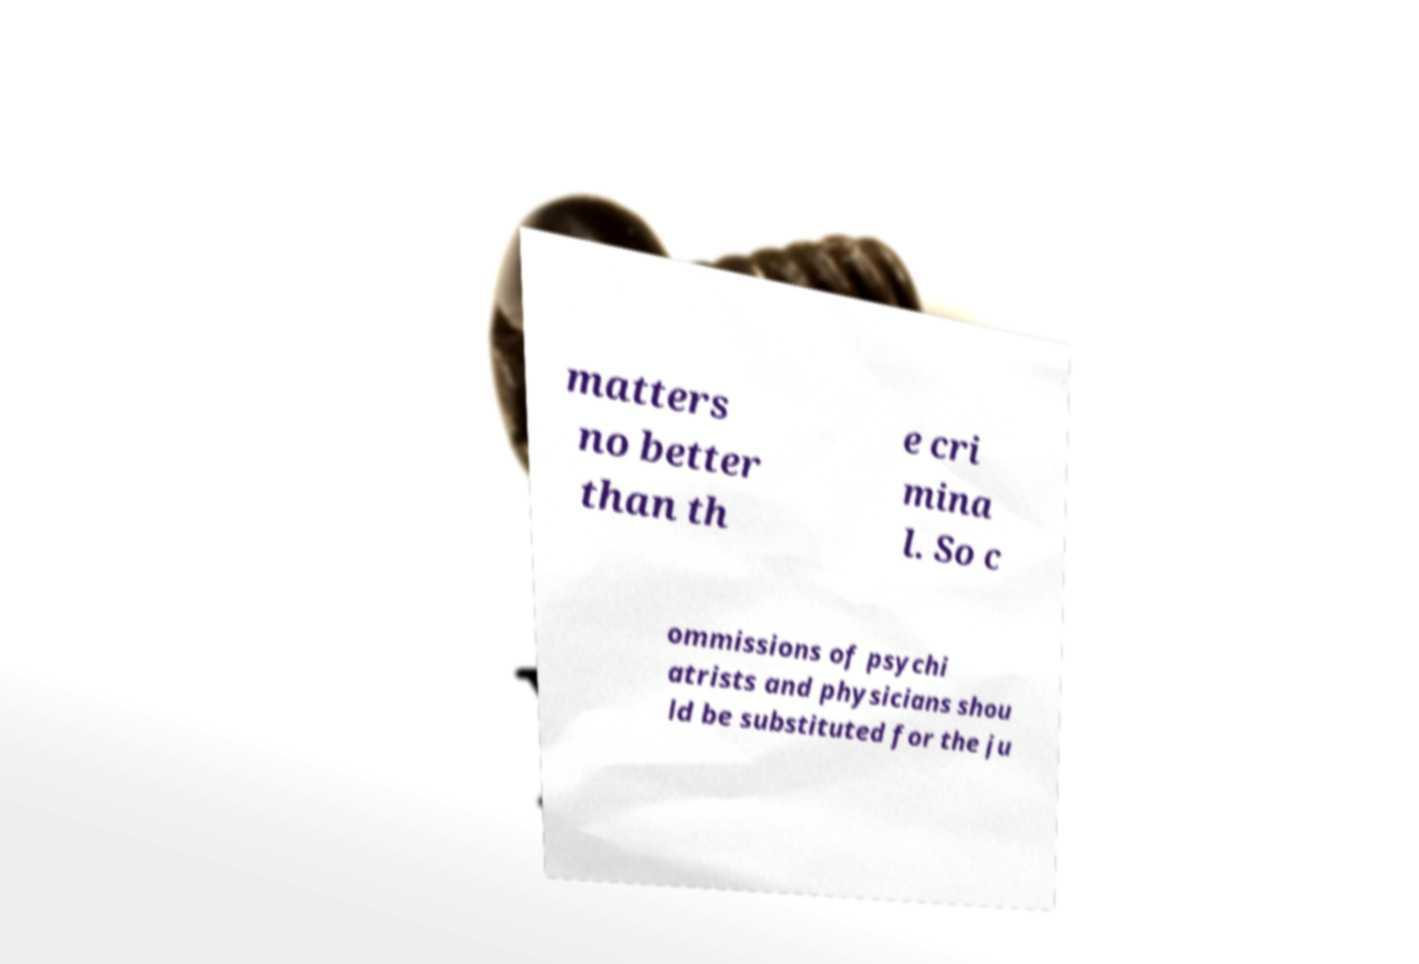For documentation purposes, I need the text within this image transcribed. Could you provide that? matters no better than th e cri mina l. So c ommissions of psychi atrists and physicians shou ld be substituted for the ju 